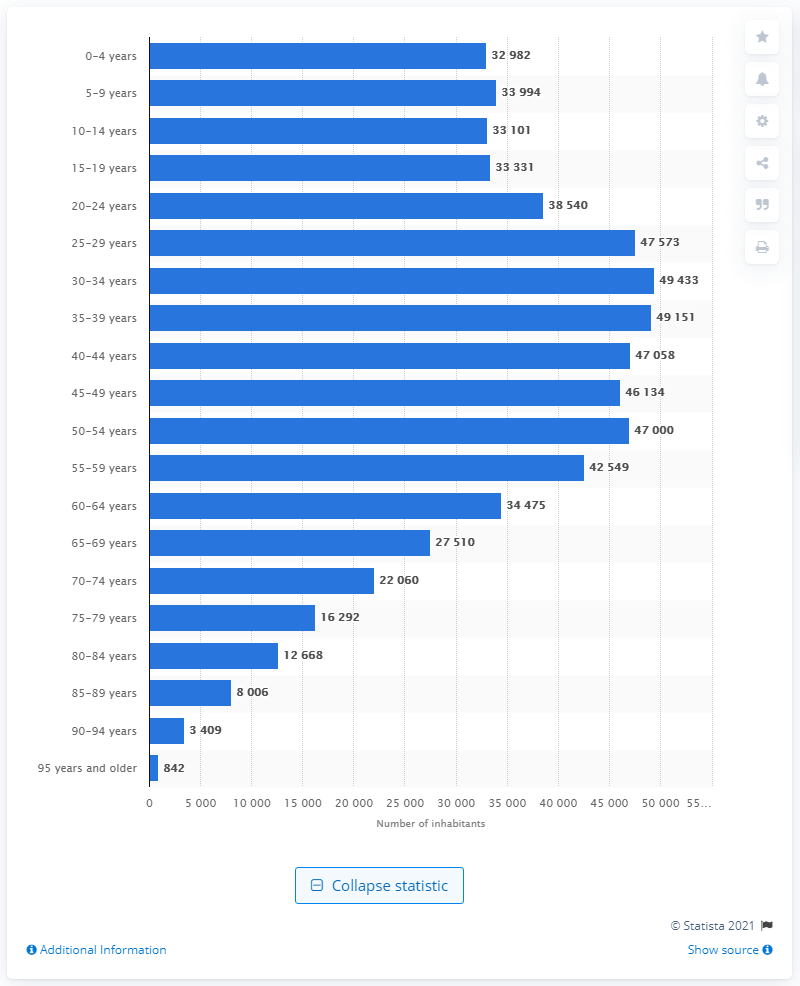Specify some key components in this picture. In 2020, the number of people who were 95 years or older in Luxembourg was 842. 